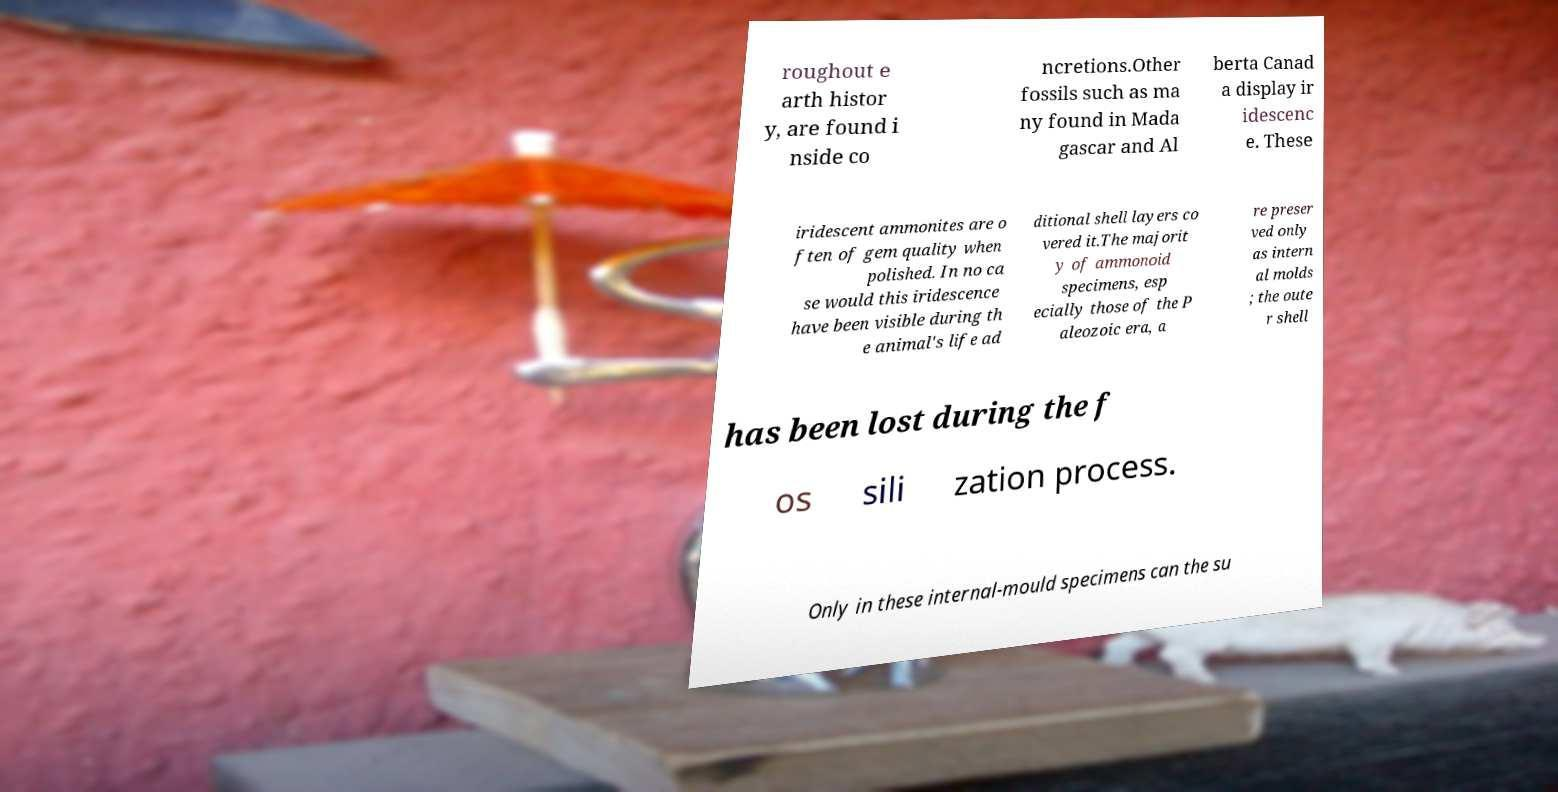For documentation purposes, I need the text within this image transcribed. Could you provide that? roughout e arth histor y, are found i nside co ncretions.Other fossils such as ma ny found in Mada gascar and Al berta Canad a display ir idescenc e. These iridescent ammonites are o ften of gem quality when polished. In no ca se would this iridescence have been visible during th e animal's life ad ditional shell layers co vered it.The majorit y of ammonoid specimens, esp ecially those of the P aleozoic era, a re preser ved only as intern al molds ; the oute r shell has been lost during the f os sili zation process. Only in these internal-mould specimens can the su 